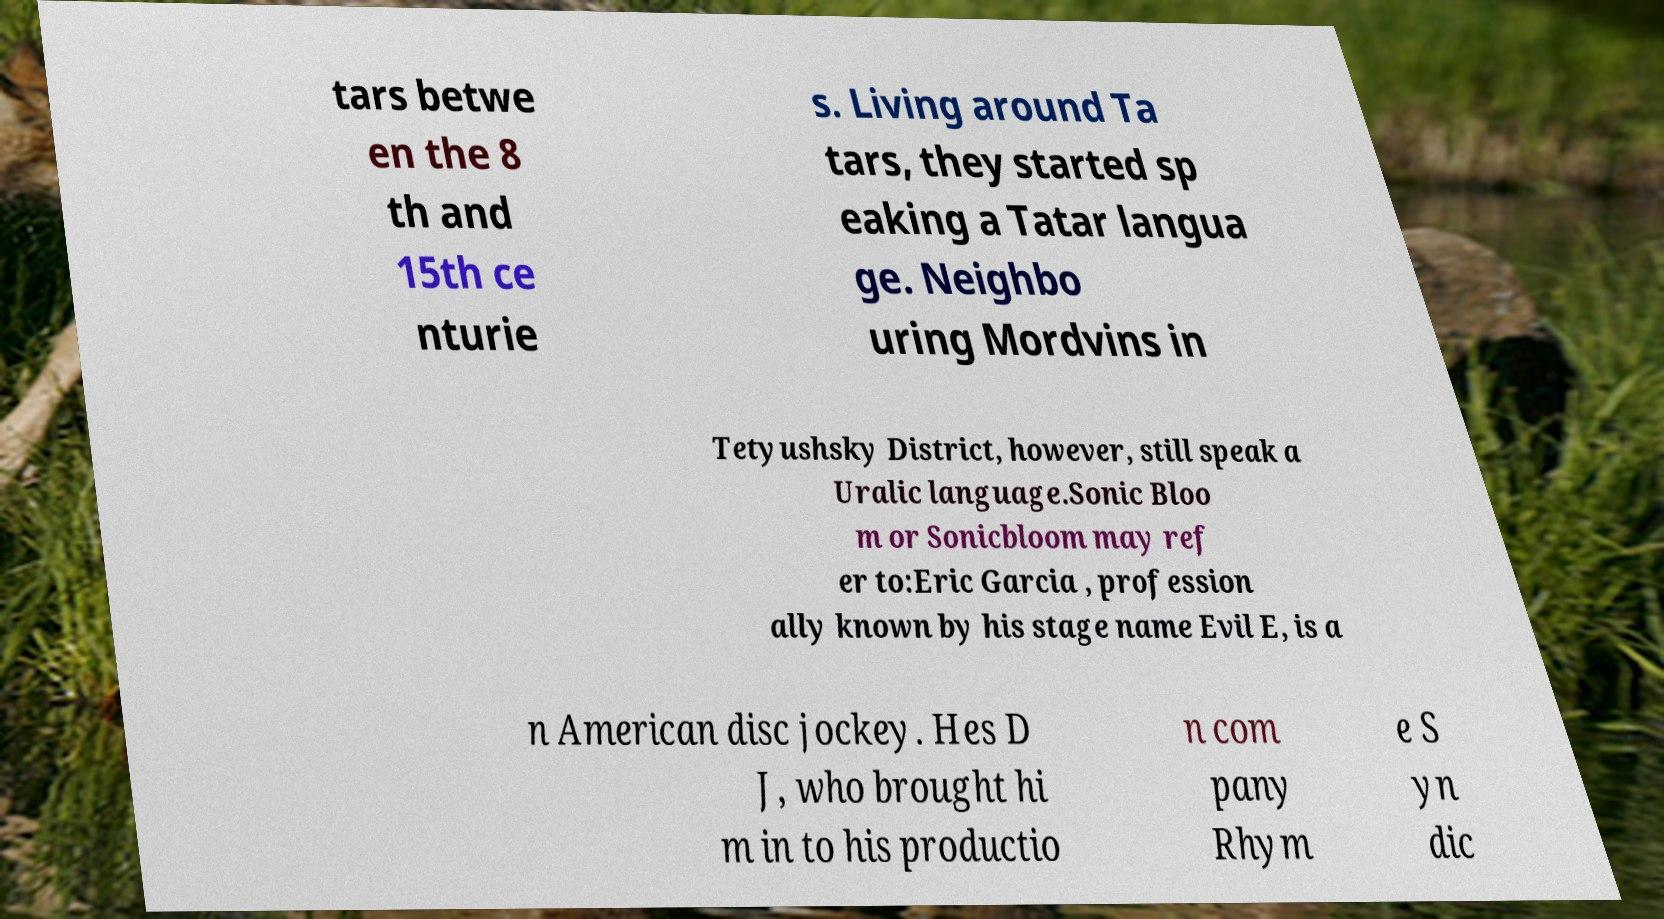Please read and relay the text visible in this image. What does it say? tars betwe en the 8 th and 15th ce nturie s. Living around Ta tars, they started sp eaking a Tatar langua ge. Neighbo uring Mordvins in Tetyushsky District, however, still speak a Uralic language.Sonic Bloo m or Sonicbloom may ref er to:Eric Garcia , profession ally known by his stage name Evil E, is a n American disc jockey. Hes D J, who brought hi m in to his productio n com pany Rhym e S yn dic 